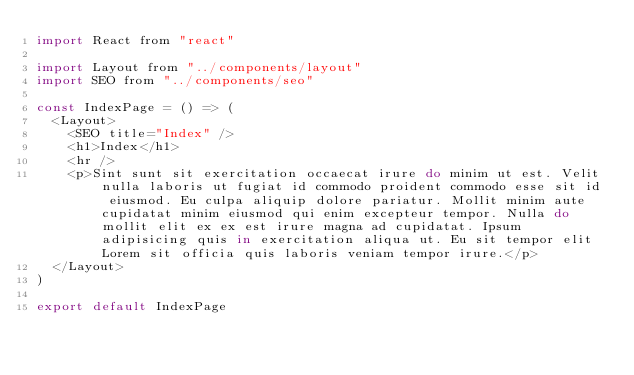Convert code to text. <code><loc_0><loc_0><loc_500><loc_500><_JavaScript_>import React from "react"

import Layout from "../components/layout"
import SEO from "../components/seo"

const IndexPage = () => (
  <Layout>
    <SEO title="Index" />
    <h1>Index</h1>
    <hr />
    <p>Sint sunt sit exercitation occaecat irure do minim ut est. Velit nulla laboris ut fugiat id commodo proident commodo esse sit id eiusmod. Eu culpa aliquip dolore pariatur. Mollit minim aute cupidatat minim eiusmod qui enim excepteur tempor. Nulla do mollit elit ex ex est irure magna ad cupidatat. Ipsum adipisicing quis in exercitation aliqua ut. Eu sit tempor elit Lorem sit officia quis laboris veniam tempor irure.</p>
  </Layout>
)

export default IndexPage
</code> 